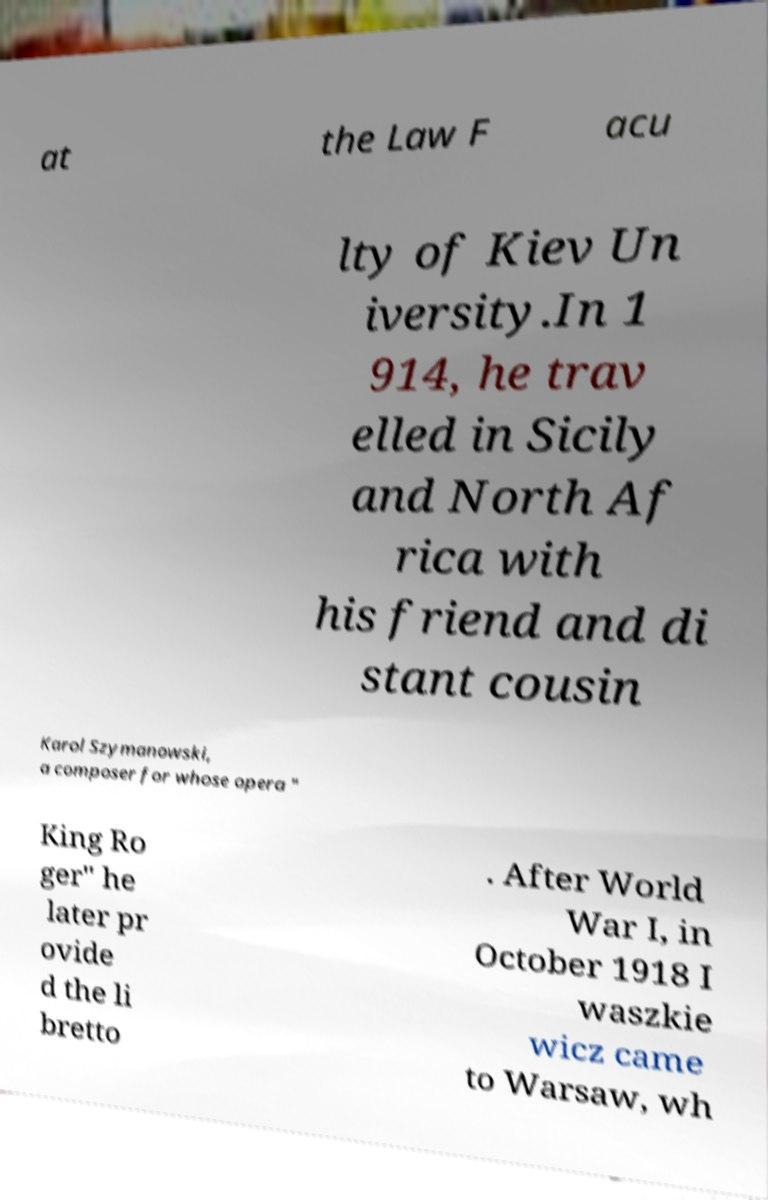Please identify and transcribe the text found in this image. at the Law F acu lty of Kiev Un iversity.In 1 914, he trav elled in Sicily and North Af rica with his friend and di stant cousin Karol Szymanowski, a composer for whose opera " King Ro ger" he later pr ovide d the li bretto . After World War I, in October 1918 I waszkie wicz came to Warsaw, wh 